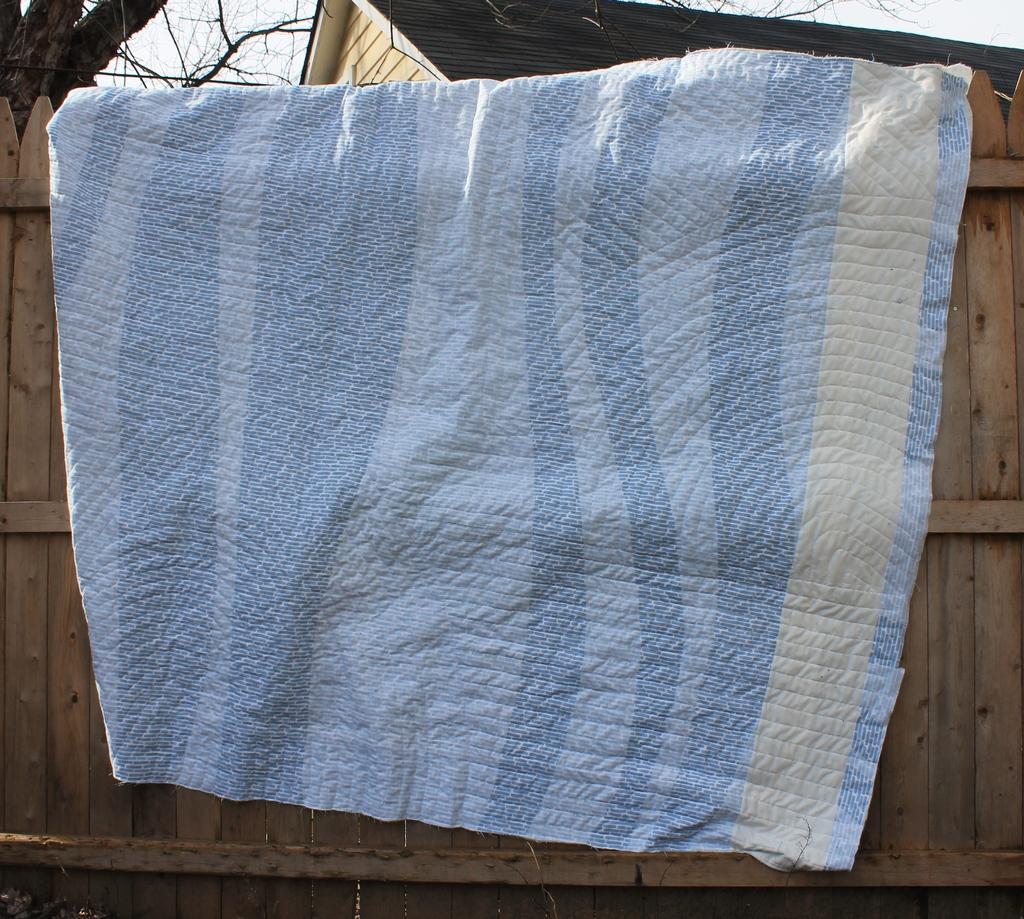In one or two sentences, can you explain what this image depicts? There is blue color cloth placed on a wooden fence wall. 